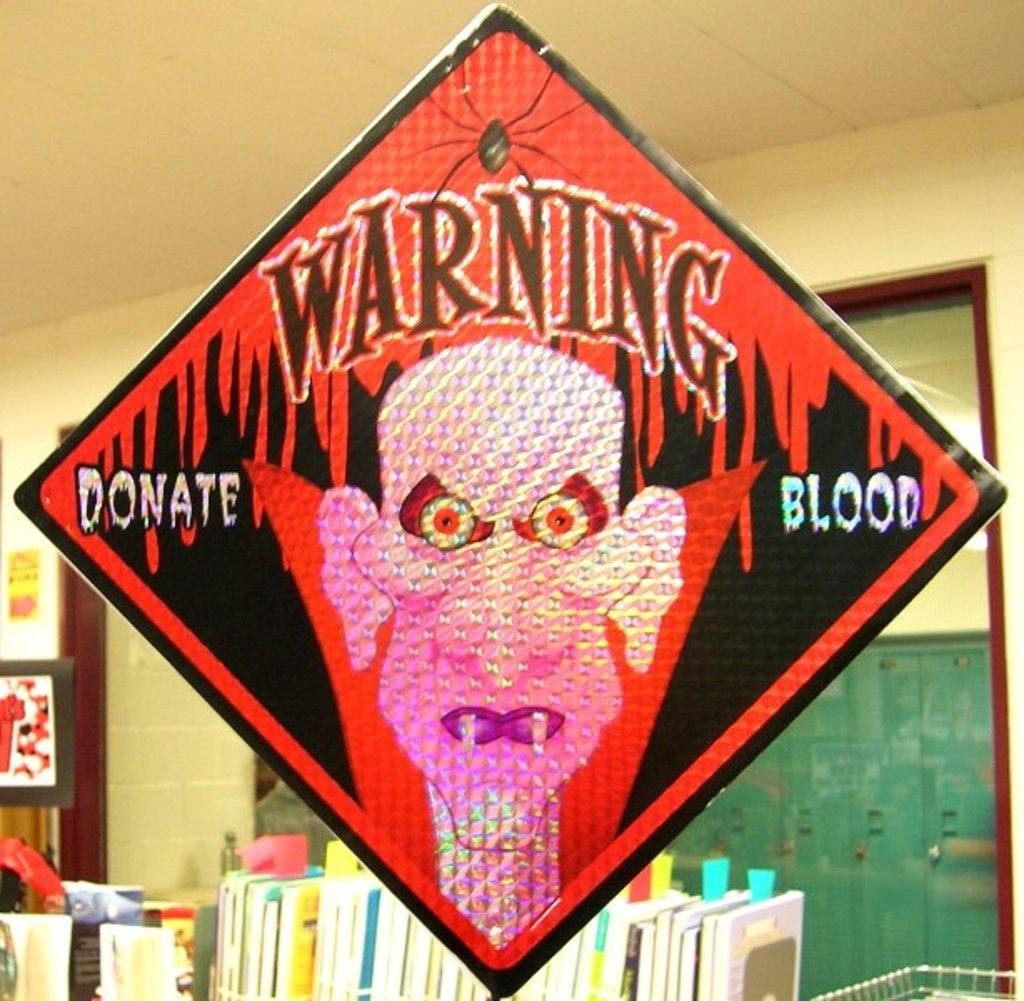<image>
Present a compact description of the photo's key features. A sign with a vampire that says Warning Donate Blood. 